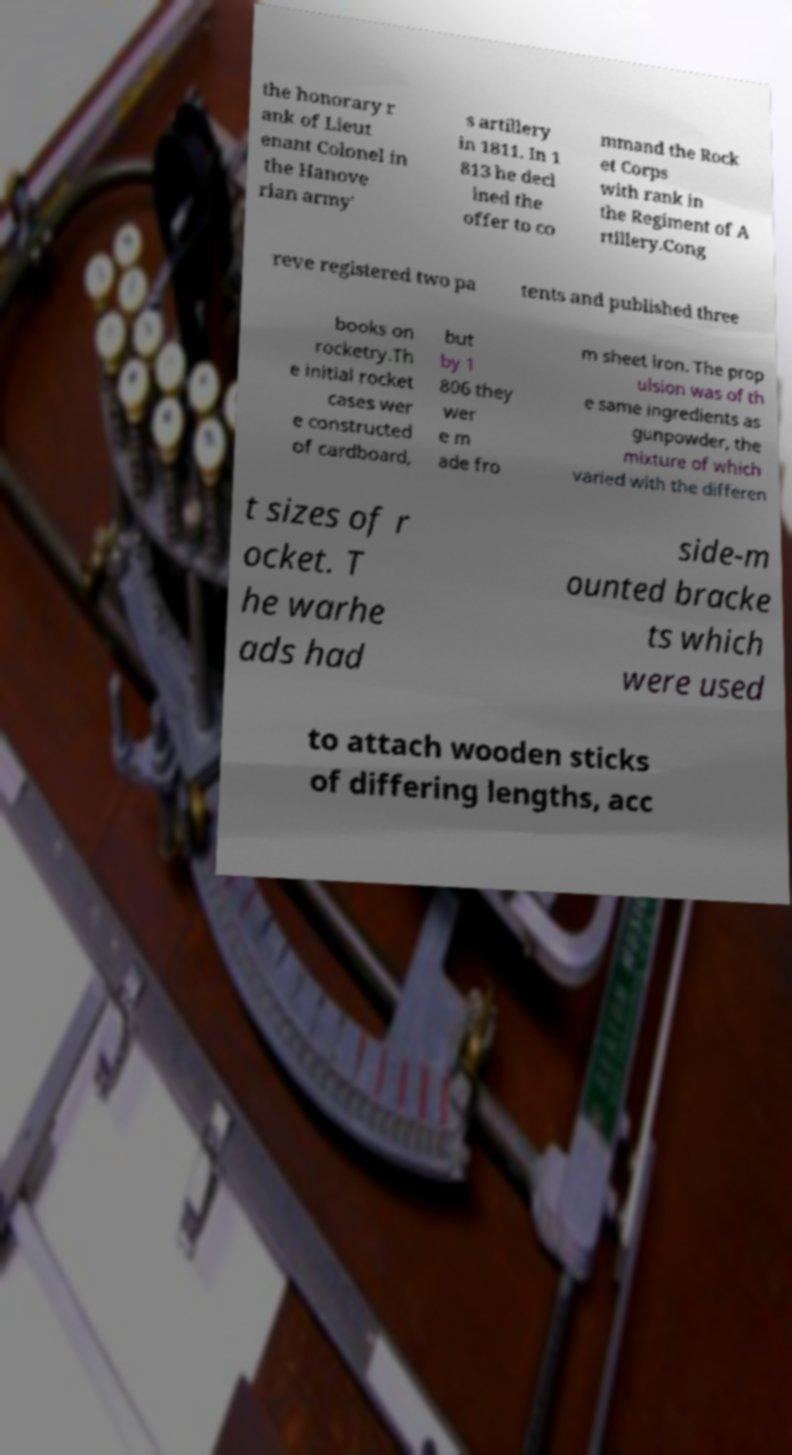What messages or text are displayed in this image? I need them in a readable, typed format. the honorary r ank of Lieut enant Colonel in the Hanove rian army' s artillery in 1811. In 1 813 he decl ined the offer to co mmand the Rock et Corps with rank in the Regiment of A rtillery.Cong reve registered two pa tents and published three books on rocketry.Th e initial rocket cases wer e constructed of cardboard, but by 1 806 they wer e m ade fro m sheet iron. The prop ulsion was of th e same ingredients as gunpowder, the mixture of which varied with the differen t sizes of r ocket. T he warhe ads had side-m ounted bracke ts which were used to attach wooden sticks of differing lengths, acc 